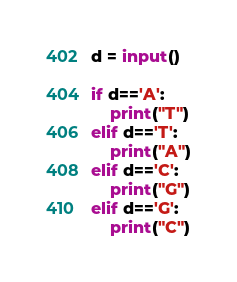<code> <loc_0><loc_0><loc_500><loc_500><_Python_>d = input()

if d=='A':
    print("T")
elif d=='T':
    print("A")
elif d=='C':
    print("G")
elif d=='G':
    print("C")
</code> 